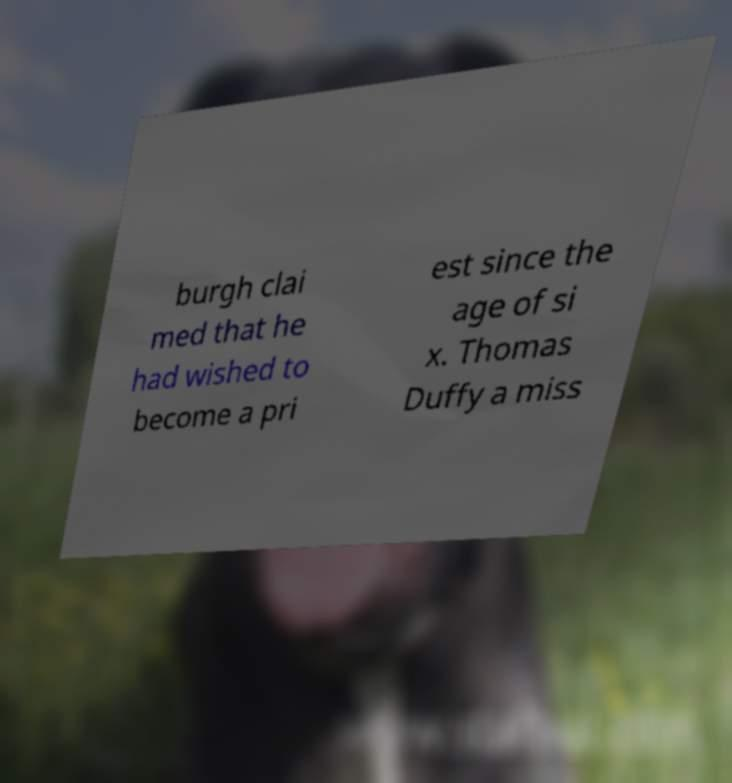Can you accurately transcribe the text from the provided image for me? burgh clai med that he had wished to become a pri est since the age of si x. Thomas Duffy a miss 